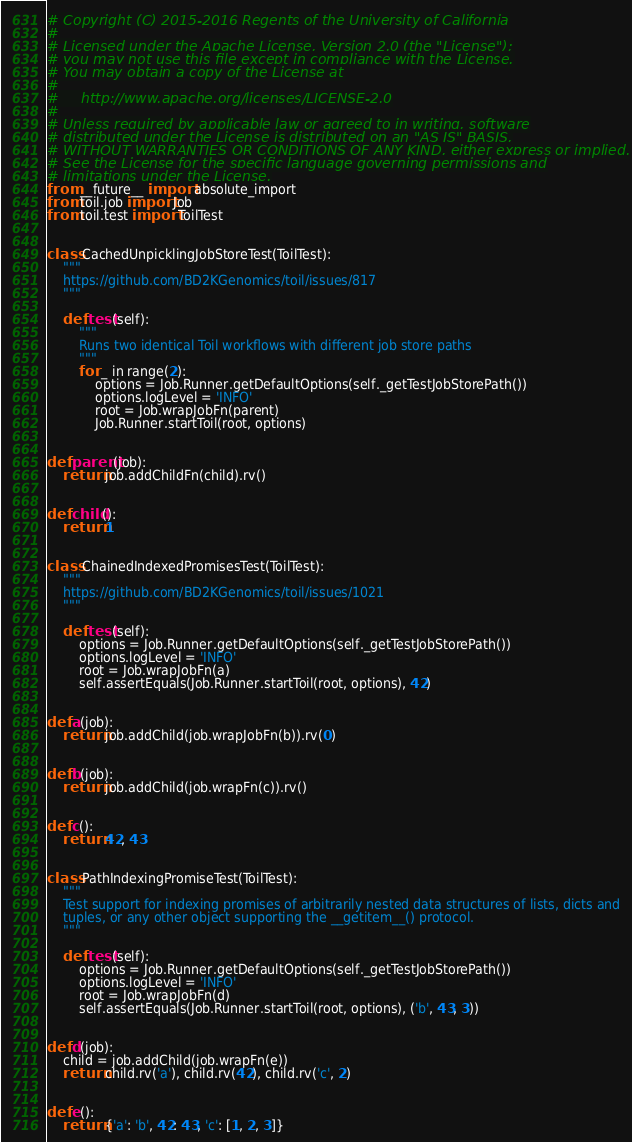Convert code to text. <code><loc_0><loc_0><loc_500><loc_500><_Python_># Copyright (C) 2015-2016 Regents of the University of California
#
# Licensed under the Apache License, Version 2.0 (the "License");
# you may not use this file except in compliance with the License.
# You may obtain a copy of the License at
#
#     http://www.apache.org/licenses/LICENSE-2.0
#
# Unless required by applicable law or agreed to in writing, software
# distributed under the License is distributed on an "AS IS" BASIS,
# WITHOUT WARRANTIES OR CONDITIONS OF ANY KIND, either express or implied.
# See the License for the specific language governing permissions and
# limitations under the License.
from __future__ import absolute_import
from toil.job import Job
from toil.test import ToilTest


class CachedUnpicklingJobStoreTest(ToilTest):
    """
    https://github.com/BD2KGenomics/toil/issues/817
    """

    def test(self):
        """
        Runs two identical Toil workflows with different job store paths
        """
        for _ in range(2):
            options = Job.Runner.getDefaultOptions(self._getTestJobStorePath())
            options.logLevel = 'INFO'
            root = Job.wrapJobFn(parent)
            Job.Runner.startToil(root, options)


def parent(job):
    return job.addChildFn(child).rv()


def child():
    return 1


class ChainedIndexedPromisesTest(ToilTest):
    """
    https://github.com/BD2KGenomics/toil/issues/1021
    """

    def test(self):
        options = Job.Runner.getDefaultOptions(self._getTestJobStorePath())
        options.logLevel = 'INFO'
        root = Job.wrapJobFn(a)
        self.assertEquals(Job.Runner.startToil(root, options), 42)


def a(job):
    return job.addChild(job.wrapJobFn(b)).rv(0)


def b(job):
    return job.addChild(job.wrapFn(c)).rv()


def c():
    return 42, 43


class PathIndexingPromiseTest(ToilTest):
    """
    Test support for indexing promises of arbitrarily nested data structures of lists, dicts and
    tuples, or any other object supporting the __getitem__() protocol.
    """

    def test(self):
        options = Job.Runner.getDefaultOptions(self._getTestJobStorePath())
        options.logLevel = 'INFO'
        root = Job.wrapJobFn(d)
        self.assertEquals(Job.Runner.startToil(root, options), ('b', 43, 3))


def d(job):
    child = job.addChild(job.wrapFn(e))
    return child.rv('a'), child.rv(42), child.rv('c', 2)


def e():
    return {'a': 'b', 42: 43, 'c': [1, 2, 3]}
</code> 